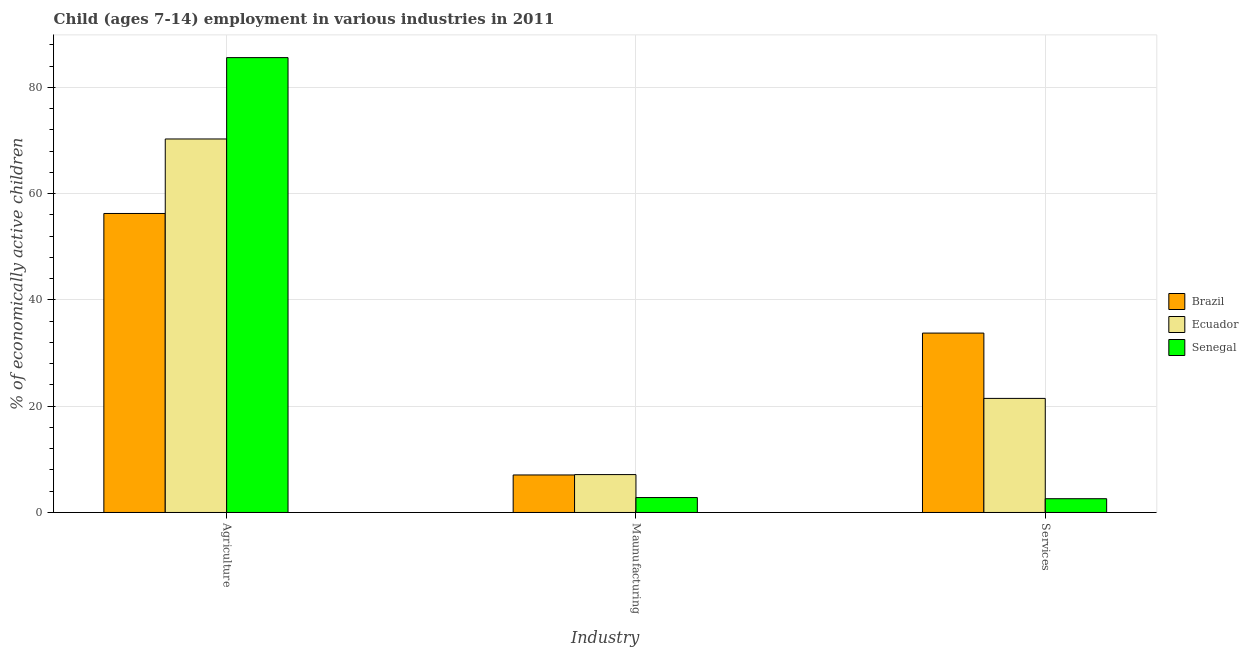How many different coloured bars are there?
Your answer should be compact. 3. How many bars are there on the 3rd tick from the right?
Give a very brief answer. 3. What is the label of the 3rd group of bars from the left?
Provide a succinct answer. Services. What is the percentage of economically active children in manufacturing in Brazil?
Give a very brief answer. 7.06. Across all countries, what is the maximum percentage of economically active children in manufacturing?
Ensure brevity in your answer.  7.13. Across all countries, what is the minimum percentage of economically active children in services?
Offer a very short reply. 2.59. In which country was the percentage of economically active children in agriculture maximum?
Give a very brief answer. Senegal. In which country was the percentage of economically active children in services minimum?
Your response must be concise. Senegal. What is the total percentage of economically active children in services in the graph?
Offer a very short reply. 57.82. What is the difference between the percentage of economically active children in services in Senegal and that in Ecuador?
Your answer should be compact. -18.88. What is the difference between the percentage of economically active children in agriculture in Ecuador and the percentage of economically active children in manufacturing in Brazil?
Keep it short and to the point. 63.23. What is the average percentage of economically active children in manufacturing per country?
Keep it short and to the point. 5.67. What is the difference between the percentage of economically active children in services and percentage of economically active children in manufacturing in Brazil?
Offer a very short reply. 26.7. What is the ratio of the percentage of economically active children in manufacturing in Ecuador to that in Senegal?
Offer a terse response. 2.54. Is the difference between the percentage of economically active children in manufacturing in Ecuador and Brazil greater than the difference between the percentage of economically active children in agriculture in Ecuador and Brazil?
Keep it short and to the point. No. What is the difference between the highest and the second highest percentage of economically active children in manufacturing?
Ensure brevity in your answer.  0.07. What is the difference between the highest and the lowest percentage of economically active children in manufacturing?
Provide a short and direct response. 4.32. What does the 3rd bar from the left in Maunufacturing represents?
Make the answer very short. Senegal. What does the 2nd bar from the right in Maunufacturing represents?
Your response must be concise. Ecuador. Is it the case that in every country, the sum of the percentage of economically active children in agriculture and percentage of economically active children in manufacturing is greater than the percentage of economically active children in services?
Provide a short and direct response. Yes. Are all the bars in the graph horizontal?
Provide a succinct answer. No. What is the title of the graph?
Provide a short and direct response. Child (ages 7-14) employment in various industries in 2011. Does "Indonesia" appear as one of the legend labels in the graph?
Give a very brief answer. No. What is the label or title of the X-axis?
Your response must be concise. Industry. What is the label or title of the Y-axis?
Give a very brief answer. % of economically active children. What is the % of economically active children in Brazil in Agriculture?
Provide a succinct answer. 56.27. What is the % of economically active children of Ecuador in Agriculture?
Offer a terse response. 70.29. What is the % of economically active children of Senegal in Agriculture?
Provide a succinct answer. 85.6. What is the % of economically active children in Brazil in Maunufacturing?
Offer a very short reply. 7.06. What is the % of economically active children in Ecuador in Maunufacturing?
Provide a short and direct response. 7.13. What is the % of economically active children in Senegal in Maunufacturing?
Your response must be concise. 2.81. What is the % of economically active children of Brazil in Services?
Give a very brief answer. 33.76. What is the % of economically active children in Ecuador in Services?
Make the answer very short. 21.47. What is the % of economically active children in Senegal in Services?
Offer a very short reply. 2.59. Across all Industry, what is the maximum % of economically active children of Brazil?
Your answer should be compact. 56.27. Across all Industry, what is the maximum % of economically active children in Ecuador?
Ensure brevity in your answer.  70.29. Across all Industry, what is the maximum % of economically active children in Senegal?
Your answer should be very brief. 85.6. Across all Industry, what is the minimum % of economically active children of Brazil?
Offer a terse response. 7.06. Across all Industry, what is the minimum % of economically active children of Ecuador?
Ensure brevity in your answer.  7.13. Across all Industry, what is the minimum % of economically active children in Senegal?
Offer a very short reply. 2.59. What is the total % of economically active children in Brazil in the graph?
Offer a terse response. 97.09. What is the total % of economically active children of Ecuador in the graph?
Your response must be concise. 98.89. What is the total % of economically active children of Senegal in the graph?
Your answer should be very brief. 91. What is the difference between the % of economically active children of Brazil in Agriculture and that in Maunufacturing?
Ensure brevity in your answer.  49.21. What is the difference between the % of economically active children of Ecuador in Agriculture and that in Maunufacturing?
Your response must be concise. 63.16. What is the difference between the % of economically active children of Senegal in Agriculture and that in Maunufacturing?
Your response must be concise. 82.79. What is the difference between the % of economically active children of Brazil in Agriculture and that in Services?
Your answer should be compact. 22.51. What is the difference between the % of economically active children of Ecuador in Agriculture and that in Services?
Offer a very short reply. 48.82. What is the difference between the % of economically active children in Senegal in Agriculture and that in Services?
Provide a short and direct response. 83.01. What is the difference between the % of economically active children in Brazil in Maunufacturing and that in Services?
Your response must be concise. -26.7. What is the difference between the % of economically active children in Ecuador in Maunufacturing and that in Services?
Give a very brief answer. -14.34. What is the difference between the % of economically active children of Senegal in Maunufacturing and that in Services?
Make the answer very short. 0.22. What is the difference between the % of economically active children in Brazil in Agriculture and the % of economically active children in Ecuador in Maunufacturing?
Give a very brief answer. 49.14. What is the difference between the % of economically active children in Brazil in Agriculture and the % of economically active children in Senegal in Maunufacturing?
Provide a short and direct response. 53.46. What is the difference between the % of economically active children in Ecuador in Agriculture and the % of economically active children in Senegal in Maunufacturing?
Provide a succinct answer. 67.48. What is the difference between the % of economically active children of Brazil in Agriculture and the % of economically active children of Ecuador in Services?
Make the answer very short. 34.8. What is the difference between the % of economically active children in Brazil in Agriculture and the % of economically active children in Senegal in Services?
Provide a short and direct response. 53.68. What is the difference between the % of economically active children of Ecuador in Agriculture and the % of economically active children of Senegal in Services?
Keep it short and to the point. 67.7. What is the difference between the % of economically active children of Brazil in Maunufacturing and the % of economically active children of Ecuador in Services?
Provide a short and direct response. -14.41. What is the difference between the % of economically active children of Brazil in Maunufacturing and the % of economically active children of Senegal in Services?
Give a very brief answer. 4.47. What is the difference between the % of economically active children in Ecuador in Maunufacturing and the % of economically active children in Senegal in Services?
Provide a succinct answer. 4.54. What is the average % of economically active children of Brazil per Industry?
Offer a terse response. 32.36. What is the average % of economically active children in Ecuador per Industry?
Keep it short and to the point. 32.96. What is the average % of economically active children of Senegal per Industry?
Provide a short and direct response. 30.33. What is the difference between the % of economically active children of Brazil and % of economically active children of Ecuador in Agriculture?
Your answer should be very brief. -14.02. What is the difference between the % of economically active children of Brazil and % of economically active children of Senegal in Agriculture?
Your answer should be compact. -29.33. What is the difference between the % of economically active children in Ecuador and % of economically active children in Senegal in Agriculture?
Ensure brevity in your answer.  -15.31. What is the difference between the % of economically active children of Brazil and % of economically active children of Ecuador in Maunufacturing?
Offer a terse response. -0.07. What is the difference between the % of economically active children of Brazil and % of economically active children of Senegal in Maunufacturing?
Ensure brevity in your answer.  4.25. What is the difference between the % of economically active children in Ecuador and % of economically active children in Senegal in Maunufacturing?
Provide a succinct answer. 4.32. What is the difference between the % of economically active children of Brazil and % of economically active children of Ecuador in Services?
Your response must be concise. 12.29. What is the difference between the % of economically active children in Brazil and % of economically active children in Senegal in Services?
Make the answer very short. 31.17. What is the difference between the % of economically active children of Ecuador and % of economically active children of Senegal in Services?
Make the answer very short. 18.88. What is the ratio of the % of economically active children in Brazil in Agriculture to that in Maunufacturing?
Offer a terse response. 7.97. What is the ratio of the % of economically active children in Ecuador in Agriculture to that in Maunufacturing?
Give a very brief answer. 9.86. What is the ratio of the % of economically active children in Senegal in Agriculture to that in Maunufacturing?
Your response must be concise. 30.46. What is the ratio of the % of economically active children in Brazil in Agriculture to that in Services?
Make the answer very short. 1.67. What is the ratio of the % of economically active children of Ecuador in Agriculture to that in Services?
Your answer should be compact. 3.27. What is the ratio of the % of economically active children of Senegal in Agriculture to that in Services?
Your answer should be very brief. 33.05. What is the ratio of the % of economically active children in Brazil in Maunufacturing to that in Services?
Provide a short and direct response. 0.21. What is the ratio of the % of economically active children of Ecuador in Maunufacturing to that in Services?
Provide a succinct answer. 0.33. What is the ratio of the % of economically active children of Senegal in Maunufacturing to that in Services?
Offer a terse response. 1.08. What is the difference between the highest and the second highest % of economically active children of Brazil?
Provide a succinct answer. 22.51. What is the difference between the highest and the second highest % of economically active children in Ecuador?
Your response must be concise. 48.82. What is the difference between the highest and the second highest % of economically active children in Senegal?
Your answer should be very brief. 82.79. What is the difference between the highest and the lowest % of economically active children in Brazil?
Your answer should be compact. 49.21. What is the difference between the highest and the lowest % of economically active children of Ecuador?
Ensure brevity in your answer.  63.16. What is the difference between the highest and the lowest % of economically active children of Senegal?
Your answer should be compact. 83.01. 